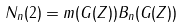<formula> <loc_0><loc_0><loc_500><loc_500>N _ { n } ( 2 ) = m ( G ( Z ) ) B _ { n } ( G ( Z ) )</formula> 